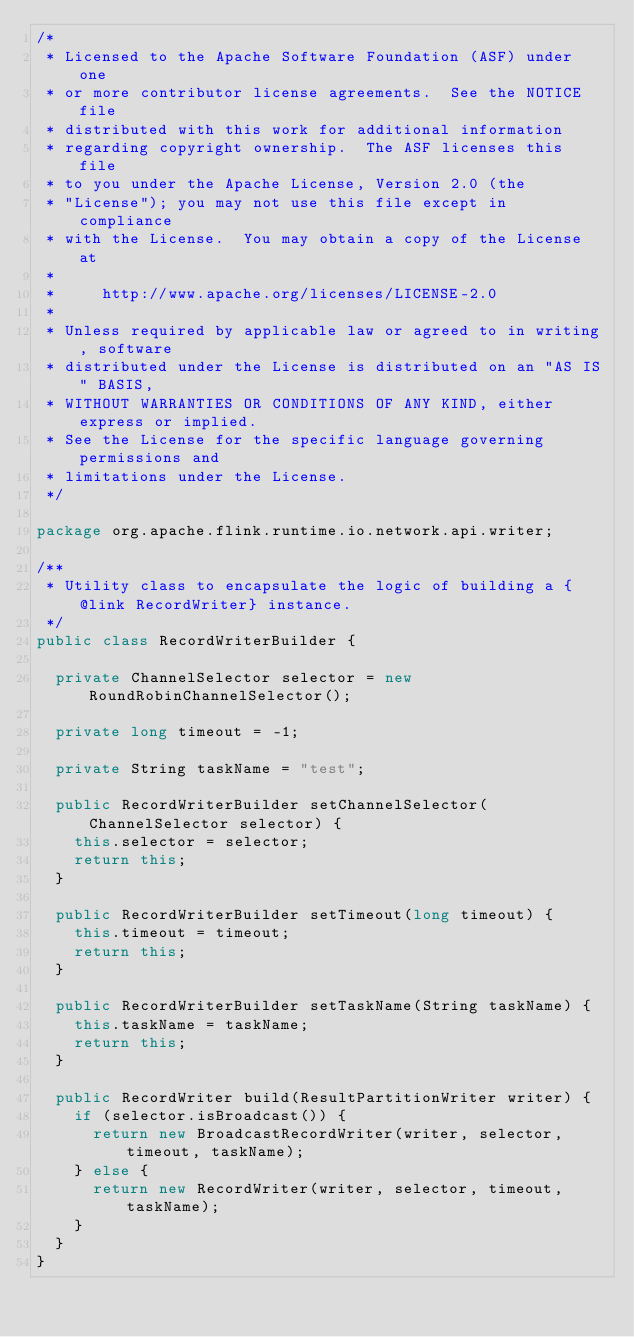<code> <loc_0><loc_0><loc_500><loc_500><_Java_>/*
 * Licensed to the Apache Software Foundation (ASF) under one
 * or more contributor license agreements.  See the NOTICE file
 * distributed with this work for additional information
 * regarding copyright ownership.  The ASF licenses this file
 * to you under the Apache License, Version 2.0 (the
 * "License"); you may not use this file except in compliance
 * with the License.  You may obtain a copy of the License at
 *
 *     http://www.apache.org/licenses/LICENSE-2.0
 *
 * Unless required by applicable law or agreed to in writing, software
 * distributed under the License is distributed on an "AS IS" BASIS,
 * WITHOUT WARRANTIES OR CONDITIONS OF ANY KIND, either express or implied.
 * See the License for the specific language governing permissions and
 * limitations under the License.
 */

package org.apache.flink.runtime.io.network.api.writer;

/**
 * Utility class to encapsulate the logic of building a {@link RecordWriter} instance.
 */
public class RecordWriterBuilder {

	private ChannelSelector selector = new RoundRobinChannelSelector();

	private long timeout = -1;

	private String taskName = "test";

	public RecordWriterBuilder setChannelSelector(ChannelSelector selector) {
		this.selector = selector;
		return this;
	}

	public RecordWriterBuilder setTimeout(long timeout) {
		this.timeout = timeout;
		return this;
	}

	public RecordWriterBuilder setTaskName(String taskName) {
		this.taskName = taskName;
		return this;
	}

	public RecordWriter build(ResultPartitionWriter writer) {
		if (selector.isBroadcast()) {
			return new BroadcastRecordWriter(writer, selector, timeout, taskName);
		} else {
			return new RecordWriter(writer, selector, timeout, taskName);
		}
	}
}
</code> 